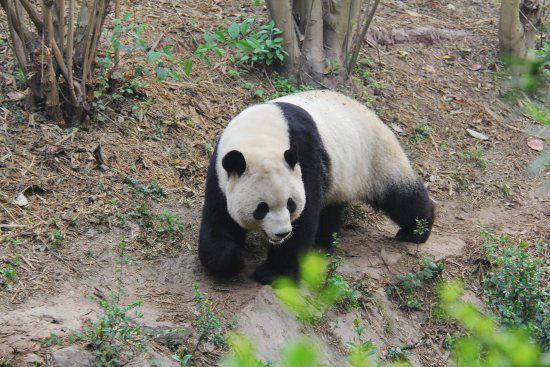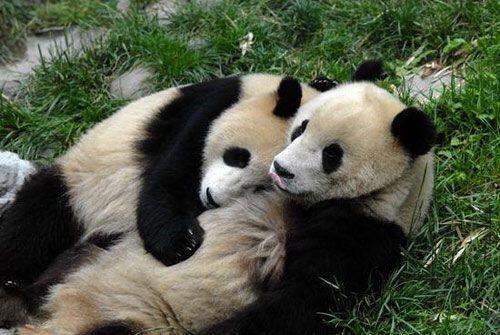The first image is the image on the left, the second image is the image on the right. Given the left and right images, does the statement "There are four pandas in the pair of images." hold true? Answer yes or no. No. The first image is the image on the left, the second image is the image on the right. Assess this claim about the two images: "There are four pandas.". Correct or not? Answer yes or no. No. 